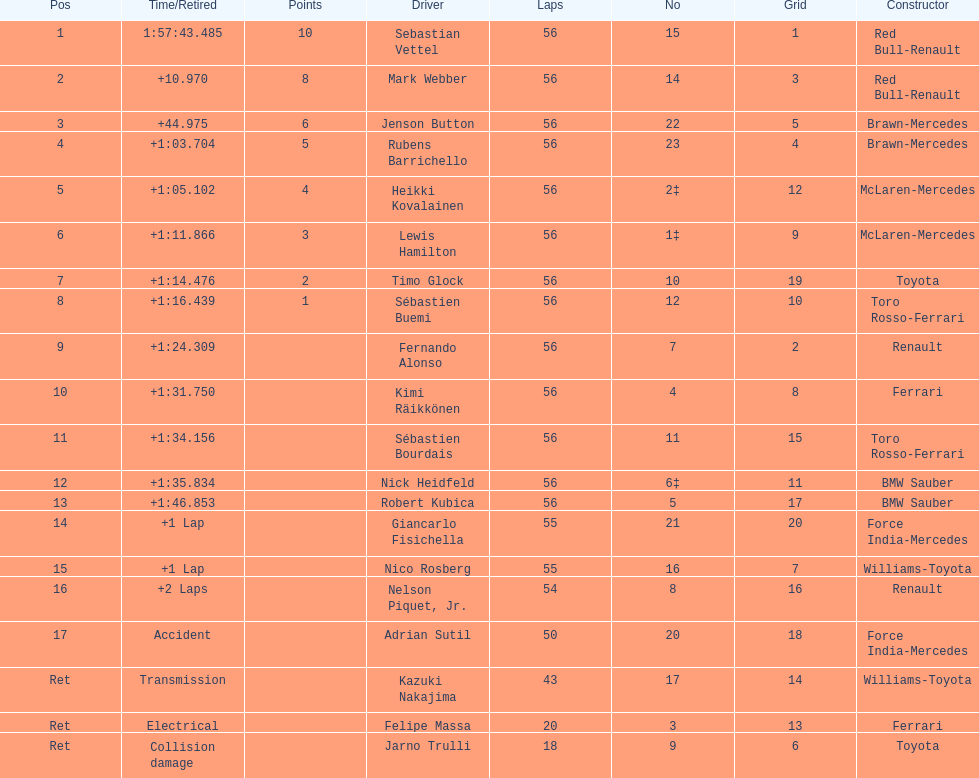What driver was last on the list? Jarno Trulli. 